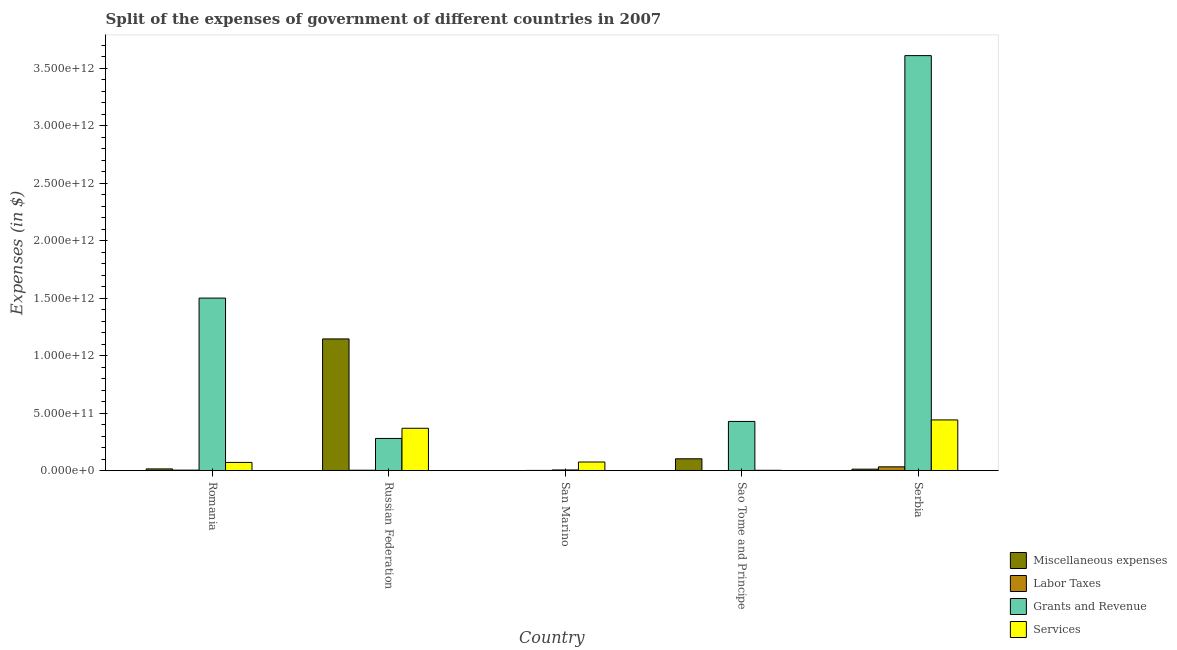How many different coloured bars are there?
Offer a terse response. 4. How many groups of bars are there?
Provide a succinct answer. 5. Are the number of bars per tick equal to the number of legend labels?
Your answer should be compact. Yes. What is the label of the 5th group of bars from the left?
Your answer should be very brief. Serbia. In how many cases, is the number of bars for a given country not equal to the number of legend labels?
Your answer should be very brief. 0. What is the amount spent on miscellaneous expenses in Romania?
Make the answer very short. 1.45e+1. Across all countries, what is the maximum amount spent on services?
Offer a very short reply. 4.41e+11. Across all countries, what is the minimum amount spent on grants and revenue?
Offer a terse response. 5.40e+09. In which country was the amount spent on labor taxes maximum?
Provide a succinct answer. Serbia. In which country was the amount spent on services minimum?
Provide a succinct answer. Sao Tome and Principe. What is the total amount spent on grants and revenue in the graph?
Give a very brief answer. 5.82e+12. What is the difference between the amount spent on services in Sao Tome and Principe and that in Serbia?
Your answer should be compact. -4.38e+11. What is the difference between the amount spent on grants and revenue in Serbia and the amount spent on services in Russian Federation?
Keep it short and to the point. 3.24e+12. What is the average amount spent on labor taxes per country?
Offer a very short reply. 8.26e+09. What is the difference between the amount spent on labor taxes and amount spent on miscellaneous expenses in San Marino?
Give a very brief answer. 1.40e+09. What is the ratio of the amount spent on services in San Marino to that in Serbia?
Provide a succinct answer. 0.17. Is the amount spent on services in Romania less than that in Russian Federation?
Provide a short and direct response. Yes. Is the difference between the amount spent on labor taxes in San Marino and Serbia greater than the difference between the amount spent on services in San Marino and Serbia?
Offer a terse response. Yes. What is the difference between the highest and the second highest amount spent on services?
Provide a short and direct response. 7.26e+1. What is the difference between the highest and the lowest amount spent on services?
Provide a short and direct response. 4.38e+11. Is the sum of the amount spent on miscellaneous expenses in Russian Federation and San Marino greater than the maximum amount spent on grants and revenue across all countries?
Provide a succinct answer. No. Is it the case that in every country, the sum of the amount spent on labor taxes and amount spent on miscellaneous expenses is greater than the sum of amount spent on services and amount spent on grants and revenue?
Your answer should be compact. No. What does the 1st bar from the left in Serbia represents?
Keep it short and to the point. Miscellaneous expenses. What does the 3rd bar from the right in Serbia represents?
Your response must be concise. Labor Taxes. What is the difference between two consecutive major ticks on the Y-axis?
Provide a succinct answer. 5.00e+11. Are the values on the major ticks of Y-axis written in scientific E-notation?
Offer a very short reply. Yes. Does the graph contain any zero values?
Your answer should be compact. No. Does the graph contain grids?
Your answer should be very brief. No. Where does the legend appear in the graph?
Your answer should be very brief. Bottom right. How many legend labels are there?
Provide a succinct answer. 4. How are the legend labels stacked?
Your answer should be very brief. Vertical. What is the title of the graph?
Offer a very short reply. Split of the expenses of government of different countries in 2007. What is the label or title of the X-axis?
Offer a terse response. Country. What is the label or title of the Y-axis?
Make the answer very short. Expenses (in $). What is the Expenses (in $) in Miscellaneous expenses in Romania?
Make the answer very short. 1.45e+1. What is the Expenses (in $) in Labor Taxes in Romania?
Give a very brief answer. 3.84e+09. What is the Expenses (in $) of Grants and Revenue in Romania?
Your answer should be very brief. 1.50e+12. What is the Expenses (in $) of Services in Romania?
Ensure brevity in your answer.  7.09e+1. What is the Expenses (in $) of Miscellaneous expenses in Russian Federation?
Your answer should be compact. 1.15e+12. What is the Expenses (in $) in Labor Taxes in Russian Federation?
Provide a succinct answer. 3.08e+09. What is the Expenses (in $) in Grants and Revenue in Russian Federation?
Your answer should be compact. 2.80e+11. What is the Expenses (in $) of Services in Russian Federation?
Your answer should be very brief. 3.68e+11. What is the Expenses (in $) of Miscellaneous expenses in San Marino?
Offer a terse response. 3.50e+07. What is the Expenses (in $) in Labor Taxes in San Marino?
Provide a short and direct response. 1.44e+09. What is the Expenses (in $) of Grants and Revenue in San Marino?
Your answer should be very brief. 5.40e+09. What is the Expenses (in $) of Services in San Marino?
Your answer should be very brief. 7.46e+1. What is the Expenses (in $) of Miscellaneous expenses in Sao Tome and Principe?
Offer a very short reply. 1.03e+11. What is the Expenses (in $) of Labor Taxes in Sao Tome and Principe?
Make the answer very short. 3.27e+08. What is the Expenses (in $) in Grants and Revenue in Sao Tome and Principe?
Make the answer very short. 4.28e+11. What is the Expenses (in $) of Services in Sao Tome and Principe?
Your answer should be very brief. 2.47e+09. What is the Expenses (in $) of Miscellaneous expenses in Serbia?
Provide a short and direct response. 1.23e+1. What is the Expenses (in $) of Labor Taxes in Serbia?
Your answer should be compact. 3.26e+1. What is the Expenses (in $) of Grants and Revenue in Serbia?
Ensure brevity in your answer.  3.61e+12. What is the Expenses (in $) of Services in Serbia?
Ensure brevity in your answer.  4.41e+11. Across all countries, what is the maximum Expenses (in $) of Miscellaneous expenses?
Make the answer very short. 1.15e+12. Across all countries, what is the maximum Expenses (in $) of Labor Taxes?
Offer a very short reply. 3.26e+1. Across all countries, what is the maximum Expenses (in $) in Grants and Revenue?
Your answer should be very brief. 3.61e+12. Across all countries, what is the maximum Expenses (in $) in Services?
Your response must be concise. 4.41e+11. Across all countries, what is the minimum Expenses (in $) in Miscellaneous expenses?
Offer a terse response. 3.50e+07. Across all countries, what is the minimum Expenses (in $) of Labor Taxes?
Your response must be concise. 3.27e+08. Across all countries, what is the minimum Expenses (in $) of Grants and Revenue?
Make the answer very short. 5.40e+09. Across all countries, what is the minimum Expenses (in $) in Services?
Provide a succinct answer. 2.47e+09. What is the total Expenses (in $) in Miscellaneous expenses in the graph?
Your answer should be compact. 1.28e+12. What is the total Expenses (in $) of Labor Taxes in the graph?
Provide a succinct answer. 4.13e+1. What is the total Expenses (in $) of Grants and Revenue in the graph?
Ensure brevity in your answer.  5.82e+12. What is the total Expenses (in $) in Services in the graph?
Give a very brief answer. 9.57e+11. What is the difference between the Expenses (in $) in Miscellaneous expenses in Romania and that in Russian Federation?
Offer a very short reply. -1.13e+12. What is the difference between the Expenses (in $) of Labor Taxes in Romania and that in Russian Federation?
Make the answer very short. 7.59e+08. What is the difference between the Expenses (in $) in Grants and Revenue in Romania and that in Russian Federation?
Your answer should be compact. 1.22e+12. What is the difference between the Expenses (in $) in Services in Romania and that in Russian Federation?
Provide a succinct answer. -2.97e+11. What is the difference between the Expenses (in $) in Miscellaneous expenses in Romania and that in San Marino?
Offer a terse response. 1.45e+1. What is the difference between the Expenses (in $) of Labor Taxes in Romania and that in San Marino?
Make the answer very short. 2.40e+09. What is the difference between the Expenses (in $) of Grants and Revenue in Romania and that in San Marino?
Ensure brevity in your answer.  1.50e+12. What is the difference between the Expenses (in $) of Services in Romania and that in San Marino?
Keep it short and to the point. -3.69e+09. What is the difference between the Expenses (in $) of Miscellaneous expenses in Romania and that in Sao Tome and Principe?
Provide a succinct answer. -8.81e+1. What is the difference between the Expenses (in $) in Labor Taxes in Romania and that in Sao Tome and Principe?
Provide a short and direct response. 3.51e+09. What is the difference between the Expenses (in $) in Grants and Revenue in Romania and that in Sao Tome and Principe?
Your response must be concise. 1.07e+12. What is the difference between the Expenses (in $) in Services in Romania and that in Sao Tome and Principe?
Your answer should be compact. 6.84e+1. What is the difference between the Expenses (in $) of Miscellaneous expenses in Romania and that in Serbia?
Ensure brevity in your answer.  2.18e+09. What is the difference between the Expenses (in $) of Labor Taxes in Romania and that in Serbia?
Make the answer very short. -2.88e+1. What is the difference between the Expenses (in $) in Grants and Revenue in Romania and that in Serbia?
Give a very brief answer. -2.11e+12. What is the difference between the Expenses (in $) of Services in Romania and that in Serbia?
Offer a terse response. -3.70e+11. What is the difference between the Expenses (in $) in Miscellaneous expenses in Russian Federation and that in San Marino?
Offer a very short reply. 1.15e+12. What is the difference between the Expenses (in $) in Labor Taxes in Russian Federation and that in San Marino?
Make the answer very short. 1.64e+09. What is the difference between the Expenses (in $) of Grants and Revenue in Russian Federation and that in San Marino?
Your response must be concise. 2.74e+11. What is the difference between the Expenses (in $) of Services in Russian Federation and that in San Marino?
Your answer should be compact. 2.94e+11. What is the difference between the Expenses (in $) in Miscellaneous expenses in Russian Federation and that in Sao Tome and Principe?
Your answer should be compact. 1.04e+12. What is the difference between the Expenses (in $) of Labor Taxes in Russian Federation and that in Sao Tome and Principe?
Provide a short and direct response. 2.75e+09. What is the difference between the Expenses (in $) of Grants and Revenue in Russian Federation and that in Sao Tome and Principe?
Offer a terse response. -1.48e+11. What is the difference between the Expenses (in $) of Services in Russian Federation and that in Sao Tome and Principe?
Your response must be concise. 3.66e+11. What is the difference between the Expenses (in $) in Miscellaneous expenses in Russian Federation and that in Serbia?
Give a very brief answer. 1.13e+12. What is the difference between the Expenses (in $) of Labor Taxes in Russian Federation and that in Serbia?
Your response must be concise. -2.95e+1. What is the difference between the Expenses (in $) of Grants and Revenue in Russian Federation and that in Serbia?
Your response must be concise. -3.33e+12. What is the difference between the Expenses (in $) in Services in Russian Federation and that in Serbia?
Provide a short and direct response. -7.26e+1. What is the difference between the Expenses (in $) in Miscellaneous expenses in San Marino and that in Sao Tome and Principe?
Make the answer very short. -1.03e+11. What is the difference between the Expenses (in $) of Labor Taxes in San Marino and that in Sao Tome and Principe?
Offer a very short reply. 1.11e+09. What is the difference between the Expenses (in $) in Grants and Revenue in San Marino and that in Sao Tome and Principe?
Ensure brevity in your answer.  -4.22e+11. What is the difference between the Expenses (in $) of Services in San Marino and that in Sao Tome and Principe?
Provide a short and direct response. 7.21e+1. What is the difference between the Expenses (in $) in Miscellaneous expenses in San Marino and that in Serbia?
Ensure brevity in your answer.  -1.23e+1. What is the difference between the Expenses (in $) in Labor Taxes in San Marino and that in Serbia?
Offer a terse response. -3.12e+1. What is the difference between the Expenses (in $) of Grants and Revenue in San Marino and that in Serbia?
Ensure brevity in your answer.  -3.61e+12. What is the difference between the Expenses (in $) of Services in San Marino and that in Serbia?
Your response must be concise. -3.66e+11. What is the difference between the Expenses (in $) of Miscellaneous expenses in Sao Tome and Principe and that in Serbia?
Provide a succinct answer. 9.03e+1. What is the difference between the Expenses (in $) in Labor Taxes in Sao Tome and Principe and that in Serbia?
Your answer should be compact. -3.23e+1. What is the difference between the Expenses (in $) of Grants and Revenue in Sao Tome and Principe and that in Serbia?
Your response must be concise. -3.18e+12. What is the difference between the Expenses (in $) of Services in Sao Tome and Principe and that in Serbia?
Make the answer very short. -4.38e+11. What is the difference between the Expenses (in $) of Miscellaneous expenses in Romania and the Expenses (in $) of Labor Taxes in Russian Federation?
Your answer should be compact. 1.14e+1. What is the difference between the Expenses (in $) of Miscellaneous expenses in Romania and the Expenses (in $) of Grants and Revenue in Russian Federation?
Your response must be concise. -2.65e+11. What is the difference between the Expenses (in $) in Miscellaneous expenses in Romania and the Expenses (in $) in Services in Russian Federation?
Offer a terse response. -3.54e+11. What is the difference between the Expenses (in $) in Labor Taxes in Romania and the Expenses (in $) in Grants and Revenue in Russian Federation?
Provide a short and direct response. -2.76e+11. What is the difference between the Expenses (in $) in Labor Taxes in Romania and the Expenses (in $) in Services in Russian Federation?
Provide a succinct answer. -3.64e+11. What is the difference between the Expenses (in $) of Grants and Revenue in Romania and the Expenses (in $) of Services in Russian Federation?
Provide a succinct answer. 1.13e+12. What is the difference between the Expenses (in $) of Miscellaneous expenses in Romania and the Expenses (in $) of Labor Taxes in San Marino?
Your answer should be very brief. 1.31e+1. What is the difference between the Expenses (in $) in Miscellaneous expenses in Romania and the Expenses (in $) in Grants and Revenue in San Marino?
Your answer should be compact. 9.11e+09. What is the difference between the Expenses (in $) of Miscellaneous expenses in Romania and the Expenses (in $) of Services in San Marino?
Ensure brevity in your answer.  -6.01e+1. What is the difference between the Expenses (in $) in Labor Taxes in Romania and the Expenses (in $) in Grants and Revenue in San Marino?
Ensure brevity in your answer.  -1.56e+09. What is the difference between the Expenses (in $) in Labor Taxes in Romania and the Expenses (in $) in Services in San Marino?
Your answer should be compact. -7.07e+1. What is the difference between the Expenses (in $) of Grants and Revenue in Romania and the Expenses (in $) of Services in San Marino?
Your response must be concise. 1.43e+12. What is the difference between the Expenses (in $) of Miscellaneous expenses in Romania and the Expenses (in $) of Labor Taxes in Sao Tome and Principe?
Your answer should be very brief. 1.42e+1. What is the difference between the Expenses (in $) of Miscellaneous expenses in Romania and the Expenses (in $) of Grants and Revenue in Sao Tome and Principe?
Offer a terse response. -4.13e+11. What is the difference between the Expenses (in $) of Miscellaneous expenses in Romania and the Expenses (in $) of Services in Sao Tome and Principe?
Make the answer very short. 1.20e+1. What is the difference between the Expenses (in $) in Labor Taxes in Romania and the Expenses (in $) in Grants and Revenue in Sao Tome and Principe?
Offer a terse response. -4.24e+11. What is the difference between the Expenses (in $) in Labor Taxes in Romania and the Expenses (in $) in Services in Sao Tome and Principe?
Offer a terse response. 1.36e+09. What is the difference between the Expenses (in $) of Grants and Revenue in Romania and the Expenses (in $) of Services in Sao Tome and Principe?
Make the answer very short. 1.50e+12. What is the difference between the Expenses (in $) in Miscellaneous expenses in Romania and the Expenses (in $) in Labor Taxes in Serbia?
Your answer should be very brief. -1.81e+1. What is the difference between the Expenses (in $) of Miscellaneous expenses in Romania and the Expenses (in $) of Grants and Revenue in Serbia?
Make the answer very short. -3.60e+12. What is the difference between the Expenses (in $) in Miscellaneous expenses in Romania and the Expenses (in $) in Services in Serbia?
Your response must be concise. -4.26e+11. What is the difference between the Expenses (in $) of Labor Taxes in Romania and the Expenses (in $) of Grants and Revenue in Serbia?
Your answer should be compact. -3.61e+12. What is the difference between the Expenses (in $) of Labor Taxes in Romania and the Expenses (in $) of Services in Serbia?
Offer a very short reply. -4.37e+11. What is the difference between the Expenses (in $) of Grants and Revenue in Romania and the Expenses (in $) of Services in Serbia?
Give a very brief answer. 1.06e+12. What is the difference between the Expenses (in $) of Miscellaneous expenses in Russian Federation and the Expenses (in $) of Labor Taxes in San Marino?
Keep it short and to the point. 1.14e+12. What is the difference between the Expenses (in $) of Miscellaneous expenses in Russian Federation and the Expenses (in $) of Grants and Revenue in San Marino?
Give a very brief answer. 1.14e+12. What is the difference between the Expenses (in $) of Miscellaneous expenses in Russian Federation and the Expenses (in $) of Services in San Marino?
Your answer should be compact. 1.07e+12. What is the difference between the Expenses (in $) of Labor Taxes in Russian Federation and the Expenses (in $) of Grants and Revenue in San Marino?
Your answer should be very brief. -2.32e+09. What is the difference between the Expenses (in $) in Labor Taxes in Russian Federation and the Expenses (in $) in Services in San Marino?
Provide a succinct answer. -7.15e+1. What is the difference between the Expenses (in $) of Grants and Revenue in Russian Federation and the Expenses (in $) of Services in San Marino?
Your answer should be compact. 2.05e+11. What is the difference between the Expenses (in $) of Miscellaneous expenses in Russian Federation and the Expenses (in $) of Labor Taxes in Sao Tome and Principe?
Offer a very short reply. 1.15e+12. What is the difference between the Expenses (in $) in Miscellaneous expenses in Russian Federation and the Expenses (in $) in Grants and Revenue in Sao Tome and Principe?
Give a very brief answer. 7.18e+11. What is the difference between the Expenses (in $) of Miscellaneous expenses in Russian Federation and the Expenses (in $) of Services in Sao Tome and Principe?
Offer a very short reply. 1.14e+12. What is the difference between the Expenses (in $) of Labor Taxes in Russian Federation and the Expenses (in $) of Grants and Revenue in Sao Tome and Principe?
Your answer should be very brief. -4.25e+11. What is the difference between the Expenses (in $) of Labor Taxes in Russian Federation and the Expenses (in $) of Services in Sao Tome and Principe?
Give a very brief answer. 6.06e+08. What is the difference between the Expenses (in $) of Grants and Revenue in Russian Federation and the Expenses (in $) of Services in Sao Tome and Principe?
Keep it short and to the point. 2.77e+11. What is the difference between the Expenses (in $) in Miscellaneous expenses in Russian Federation and the Expenses (in $) in Labor Taxes in Serbia?
Keep it short and to the point. 1.11e+12. What is the difference between the Expenses (in $) in Miscellaneous expenses in Russian Federation and the Expenses (in $) in Grants and Revenue in Serbia?
Offer a terse response. -2.46e+12. What is the difference between the Expenses (in $) in Miscellaneous expenses in Russian Federation and the Expenses (in $) in Services in Serbia?
Make the answer very short. 7.05e+11. What is the difference between the Expenses (in $) in Labor Taxes in Russian Federation and the Expenses (in $) in Grants and Revenue in Serbia?
Keep it short and to the point. -3.61e+12. What is the difference between the Expenses (in $) in Labor Taxes in Russian Federation and the Expenses (in $) in Services in Serbia?
Your answer should be compact. -4.38e+11. What is the difference between the Expenses (in $) of Grants and Revenue in Russian Federation and the Expenses (in $) of Services in Serbia?
Your answer should be very brief. -1.61e+11. What is the difference between the Expenses (in $) of Miscellaneous expenses in San Marino and the Expenses (in $) of Labor Taxes in Sao Tome and Principe?
Your answer should be compact. -2.92e+08. What is the difference between the Expenses (in $) in Miscellaneous expenses in San Marino and the Expenses (in $) in Grants and Revenue in Sao Tome and Principe?
Ensure brevity in your answer.  -4.28e+11. What is the difference between the Expenses (in $) in Miscellaneous expenses in San Marino and the Expenses (in $) in Services in Sao Tome and Principe?
Your answer should be compact. -2.44e+09. What is the difference between the Expenses (in $) of Labor Taxes in San Marino and the Expenses (in $) of Grants and Revenue in Sao Tome and Principe?
Your response must be concise. -4.26e+11. What is the difference between the Expenses (in $) of Labor Taxes in San Marino and the Expenses (in $) of Services in Sao Tome and Principe?
Provide a short and direct response. -1.04e+09. What is the difference between the Expenses (in $) in Grants and Revenue in San Marino and the Expenses (in $) in Services in Sao Tome and Principe?
Give a very brief answer. 2.93e+09. What is the difference between the Expenses (in $) of Miscellaneous expenses in San Marino and the Expenses (in $) of Labor Taxes in Serbia?
Make the answer very short. -3.26e+1. What is the difference between the Expenses (in $) of Miscellaneous expenses in San Marino and the Expenses (in $) of Grants and Revenue in Serbia?
Keep it short and to the point. -3.61e+12. What is the difference between the Expenses (in $) in Miscellaneous expenses in San Marino and the Expenses (in $) in Services in Serbia?
Make the answer very short. -4.41e+11. What is the difference between the Expenses (in $) of Labor Taxes in San Marino and the Expenses (in $) of Grants and Revenue in Serbia?
Your answer should be compact. -3.61e+12. What is the difference between the Expenses (in $) in Labor Taxes in San Marino and the Expenses (in $) in Services in Serbia?
Provide a short and direct response. -4.39e+11. What is the difference between the Expenses (in $) in Grants and Revenue in San Marino and the Expenses (in $) in Services in Serbia?
Your answer should be very brief. -4.35e+11. What is the difference between the Expenses (in $) of Miscellaneous expenses in Sao Tome and Principe and the Expenses (in $) of Labor Taxes in Serbia?
Your response must be concise. 7.00e+1. What is the difference between the Expenses (in $) of Miscellaneous expenses in Sao Tome and Principe and the Expenses (in $) of Grants and Revenue in Serbia?
Keep it short and to the point. -3.51e+12. What is the difference between the Expenses (in $) of Miscellaneous expenses in Sao Tome and Principe and the Expenses (in $) of Services in Serbia?
Your answer should be very brief. -3.38e+11. What is the difference between the Expenses (in $) of Labor Taxes in Sao Tome and Principe and the Expenses (in $) of Grants and Revenue in Serbia?
Provide a succinct answer. -3.61e+12. What is the difference between the Expenses (in $) in Labor Taxes in Sao Tome and Principe and the Expenses (in $) in Services in Serbia?
Offer a terse response. -4.40e+11. What is the difference between the Expenses (in $) of Grants and Revenue in Sao Tome and Principe and the Expenses (in $) of Services in Serbia?
Keep it short and to the point. -1.31e+1. What is the average Expenses (in $) of Miscellaneous expenses per country?
Your answer should be compact. 2.55e+11. What is the average Expenses (in $) of Labor Taxes per country?
Your response must be concise. 8.26e+09. What is the average Expenses (in $) in Grants and Revenue per country?
Provide a succinct answer. 1.16e+12. What is the average Expenses (in $) of Services per country?
Give a very brief answer. 1.91e+11. What is the difference between the Expenses (in $) in Miscellaneous expenses and Expenses (in $) in Labor Taxes in Romania?
Give a very brief answer. 1.07e+1. What is the difference between the Expenses (in $) in Miscellaneous expenses and Expenses (in $) in Grants and Revenue in Romania?
Provide a succinct answer. -1.49e+12. What is the difference between the Expenses (in $) in Miscellaneous expenses and Expenses (in $) in Services in Romania?
Give a very brief answer. -5.64e+1. What is the difference between the Expenses (in $) in Labor Taxes and Expenses (in $) in Grants and Revenue in Romania?
Make the answer very short. -1.50e+12. What is the difference between the Expenses (in $) of Labor Taxes and Expenses (in $) of Services in Romania?
Make the answer very short. -6.70e+1. What is the difference between the Expenses (in $) in Grants and Revenue and Expenses (in $) in Services in Romania?
Ensure brevity in your answer.  1.43e+12. What is the difference between the Expenses (in $) of Miscellaneous expenses and Expenses (in $) of Labor Taxes in Russian Federation?
Offer a very short reply. 1.14e+12. What is the difference between the Expenses (in $) of Miscellaneous expenses and Expenses (in $) of Grants and Revenue in Russian Federation?
Your response must be concise. 8.66e+11. What is the difference between the Expenses (in $) of Miscellaneous expenses and Expenses (in $) of Services in Russian Federation?
Your answer should be very brief. 7.77e+11. What is the difference between the Expenses (in $) of Labor Taxes and Expenses (in $) of Grants and Revenue in Russian Federation?
Give a very brief answer. -2.77e+11. What is the difference between the Expenses (in $) in Labor Taxes and Expenses (in $) in Services in Russian Federation?
Ensure brevity in your answer.  -3.65e+11. What is the difference between the Expenses (in $) in Grants and Revenue and Expenses (in $) in Services in Russian Federation?
Provide a succinct answer. -8.85e+1. What is the difference between the Expenses (in $) of Miscellaneous expenses and Expenses (in $) of Labor Taxes in San Marino?
Offer a terse response. -1.40e+09. What is the difference between the Expenses (in $) of Miscellaneous expenses and Expenses (in $) of Grants and Revenue in San Marino?
Give a very brief answer. -5.37e+09. What is the difference between the Expenses (in $) of Miscellaneous expenses and Expenses (in $) of Services in San Marino?
Keep it short and to the point. -7.45e+1. What is the difference between the Expenses (in $) in Labor Taxes and Expenses (in $) in Grants and Revenue in San Marino?
Provide a succinct answer. -3.96e+09. What is the difference between the Expenses (in $) of Labor Taxes and Expenses (in $) of Services in San Marino?
Make the answer very short. -7.31e+1. What is the difference between the Expenses (in $) in Grants and Revenue and Expenses (in $) in Services in San Marino?
Provide a succinct answer. -6.92e+1. What is the difference between the Expenses (in $) in Miscellaneous expenses and Expenses (in $) in Labor Taxes in Sao Tome and Principe?
Offer a terse response. 1.02e+11. What is the difference between the Expenses (in $) in Miscellaneous expenses and Expenses (in $) in Grants and Revenue in Sao Tome and Principe?
Your answer should be very brief. -3.25e+11. What is the difference between the Expenses (in $) in Miscellaneous expenses and Expenses (in $) in Services in Sao Tome and Principe?
Ensure brevity in your answer.  1.00e+11. What is the difference between the Expenses (in $) in Labor Taxes and Expenses (in $) in Grants and Revenue in Sao Tome and Principe?
Your answer should be compact. -4.27e+11. What is the difference between the Expenses (in $) of Labor Taxes and Expenses (in $) of Services in Sao Tome and Principe?
Give a very brief answer. -2.15e+09. What is the difference between the Expenses (in $) of Grants and Revenue and Expenses (in $) of Services in Sao Tome and Principe?
Offer a very short reply. 4.25e+11. What is the difference between the Expenses (in $) in Miscellaneous expenses and Expenses (in $) in Labor Taxes in Serbia?
Your answer should be very brief. -2.03e+1. What is the difference between the Expenses (in $) of Miscellaneous expenses and Expenses (in $) of Grants and Revenue in Serbia?
Your answer should be compact. -3.60e+12. What is the difference between the Expenses (in $) of Miscellaneous expenses and Expenses (in $) of Services in Serbia?
Provide a short and direct response. -4.28e+11. What is the difference between the Expenses (in $) in Labor Taxes and Expenses (in $) in Grants and Revenue in Serbia?
Your answer should be compact. -3.58e+12. What is the difference between the Expenses (in $) in Labor Taxes and Expenses (in $) in Services in Serbia?
Give a very brief answer. -4.08e+11. What is the difference between the Expenses (in $) of Grants and Revenue and Expenses (in $) of Services in Serbia?
Your answer should be compact. 3.17e+12. What is the ratio of the Expenses (in $) of Miscellaneous expenses in Romania to that in Russian Federation?
Your answer should be very brief. 0.01. What is the ratio of the Expenses (in $) in Labor Taxes in Romania to that in Russian Federation?
Give a very brief answer. 1.25. What is the ratio of the Expenses (in $) of Grants and Revenue in Romania to that in Russian Federation?
Keep it short and to the point. 5.37. What is the ratio of the Expenses (in $) in Services in Romania to that in Russian Federation?
Your response must be concise. 0.19. What is the ratio of the Expenses (in $) of Miscellaneous expenses in Romania to that in San Marino?
Keep it short and to the point. 414.84. What is the ratio of the Expenses (in $) of Labor Taxes in Romania to that in San Marino?
Make the answer very short. 2.67. What is the ratio of the Expenses (in $) of Grants and Revenue in Romania to that in San Marino?
Provide a short and direct response. 277.89. What is the ratio of the Expenses (in $) of Services in Romania to that in San Marino?
Your answer should be very brief. 0.95. What is the ratio of the Expenses (in $) in Miscellaneous expenses in Romania to that in Sao Tome and Principe?
Your answer should be compact. 0.14. What is the ratio of the Expenses (in $) of Labor Taxes in Romania to that in Sao Tome and Principe?
Your answer should be compact. 11.74. What is the ratio of the Expenses (in $) in Grants and Revenue in Romania to that in Sao Tome and Principe?
Ensure brevity in your answer.  3.51. What is the ratio of the Expenses (in $) in Services in Romania to that in Sao Tome and Principe?
Your answer should be very brief. 28.65. What is the ratio of the Expenses (in $) of Miscellaneous expenses in Romania to that in Serbia?
Keep it short and to the point. 1.18. What is the ratio of the Expenses (in $) of Labor Taxes in Romania to that in Serbia?
Offer a very short reply. 0.12. What is the ratio of the Expenses (in $) of Grants and Revenue in Romania to that in Serbia?
Provide a short and direct response. 0.42. What is the ratio of the Expenses (in $) of Services in Romania to that in Serbia?
Provide a short and direct response. 0.16. What is the ratio of the Expenses (in $) in Miscellaneous expenses in Russian Federation to that in San Marino?
Your answer should be compact. 3.27e+04. What is the ratio of the Expenses (in $) in Labor Taxes in Russian Federation to that in San Marino?
Your answer should be very brief. 2.14. What is the ratio of the Expenses (in $) of Grants and Revenue in Russian Federation to that in San Marino?
Give a very brief answer. 51.77. What is the ratio of the Expenses (in $) in Services in Russian Federation to that in San Marino?
Ensure brevity in your answer.  4.94. What is the ratio of the Expenses (in $) of Miscellaneous expenses in Russian Federation to that in Sao Tome and Principe?
Offer a terse response. 11.16. What is the ratio of the Expenses (in $) of Labor Taxes in Russian Federation to that in Sao Tome and Principe?
Keep it short and to the point. 9.42. What is the ratio of the Expenses (in $) in Grants and Revenue in Russian Federation to that in Sao Tome and Principe?
Keep it short and to the point. 0.65. What is the ratio of the Expenses (in $) of Services in Russian Federation to that in Sao Tome and Principe?
Offer a very short reply. 148.76. What is the ratio of the Expenses (in $) in Miscellaneous expenses in Russian Federation to that in Serbia?
Your answer should be compact. 92.88. What is the ratio of the Expenses (in $) in Labor Taxes in Russian Federation to that in Serbia?
Your answer should be very brief. 0.09. What is the ratio of the Expenses (in $) in Grants and Revenue in Russian Federation to that in Serbia?
Keep it short and to the point. 0.08. What is the ratio of the Expenses (in $) in Services in Russian Federation to that in Serbia?
Provide a succinct answer. 0.84. What is the ratio of the Expenses (in $) in Miscellaneous expenses in San Marino to that in Sao Tome and Principe?
Provide a succinct answer. 0. What is the ratio of the Expenses (in $) of Labor Taxes in San Marino to that in Sao Tome and Principe?
Ensure brevity in your answer.  4.39. What is the ratio of the Expenses (in $) of Grants and Revenue in San Marino to that in Sao Tome and Principe?
Ensure brevity in your answer.  0.01. What is the ratio of the Expenses (in $) of Services in San Marino to that in Sao Tome and Principe?
Make the answer very short. 30.14. What is the ratio of the Expenses (in $) of Miscellaneous expenses in San Marino to that in Serbia?
Offer a very short reply. 0. What is the ratio of the Expenses (in $) in Labor Taxes in San Marino to that in Serbia?
Keep it short and to the point. 0.04. What is the ratio of the Expenses (in $) in Grants and Revenue in San Marino to that in Serbia?
Offer a terse response. 0. What is the ratio of the Expenses (in $) in Services in San Marino to that in Serbia?
Your response must be concise. 0.17. What is the ratio of the Expenses (in $) of Miscellaneous expenses in Sao Tome and Principe to that in Serbia?
Offer a terse response. 8.32. What is the ratio of the Expenses (in $) of Labor Taxes in Sao Tome and Principe to that in Serbia?
Your response must be concise. 0.01. What is the ratio of the Expenses (in $) in Grants and Revenue in Sao Tome and Principe to that in Serbia?
Offer a terse response. 0.12. What is the ratio of the Expenses (in $) in Services in Sao Tome and Principe to that in Serbia?
Keep it short and to the point. 0.01. What is the difference between the highest and the second highest Expenses (in $) in Miscellaneous expenses?
Offer a very short reply. 1.04e+12. What is the difference between the highest and the second highest Expenses (in $) of Labor Taxes?
Offer a terse response. 2.88e+1. What is the difference between the highest and the second highest Expenses (in $) in Grants and Revenue?
Your response must be concise. 2.11e+12. What is the difference between the highest and the second highest Expenses (in $) of Services?
Keep it short and to the point. 7.26e+1. What is the difference between the highest and the lowest Expenses (in $) of Miscellaneous expenses?
Your response must be concise. 1.15e+12. What is the difference between the highest and the lowest Expenses (in $) of Labor Taxes?
Ensure brevity in your answer.  3.23e+1. What is the difference between the highest and the lowest Expenses (in $) of Grants and Revenue?
Your answer should be compact. 3.61e+12. What is the difference between the highest and the lowest Expenses (in $) in Services?
Your response must be concise. 4.38e+11. 